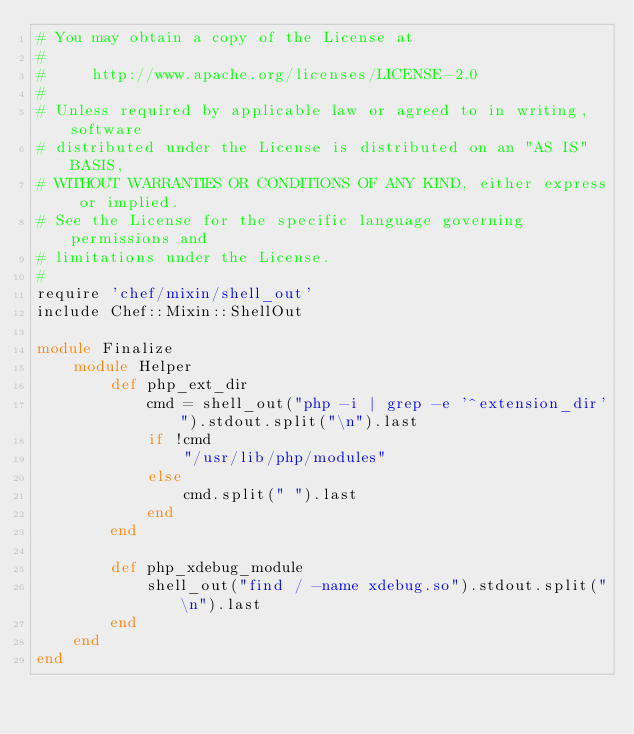Convert code to text. <code><loc_0><loc_0><loc_500><loc_500><_Ruby_># You may obtain a copy of the License at
#
#     http://www.apache.org/licenses/LICENSE-2.0
#
# Unless required by applicable law or agreed to in writing, software
# distributed under the License is distributed on an "AS IS" BASIS,
# WITHOUT WARRANTIES OR CONDITIONS OF ANY KIND, either express or implied.
# See the License for the specific language governing permissions and
# limitations under the License.
#
require 'chef/mixin/shell_out'
include Chef::Mixin::ShellOut

module Finalize
    module Helper
        def php_ext_dir
            cmd = shell_out("php -i | grep -e '^extension_dir'").stdout.split("\n").last
            if !cmd
                "/usr/lib/php/modules"
            else
                cmd.split(" ").last
            end
        end

        def php_xdebug_module
            shell_out("find / -name xdebug.so").stdout.split("\n").last
        end
    end
end</code> 